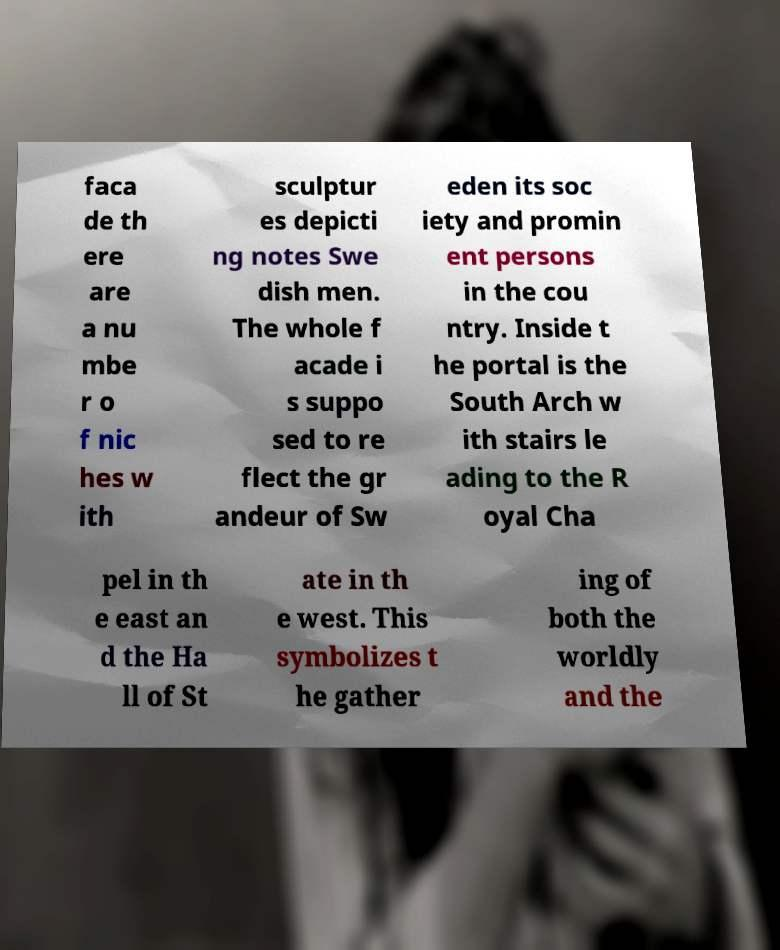Could you extract and type out the text from this image? faca de th ere are a nu mbe r o f nic hes w ith sculptur es depicti ng notes Swe dish men. The whole f acade i s suppo sed to re flect the gr andeur of Sw eden its soc iety and promin ent persons in the cou ntry. Inside t he portal is the South Arch w ith stairs le ading to the R oyal Cha pel in th e east an d the Ha ll of St ate in th e west. This symbolizes t he gather ing of both the worldly and the 